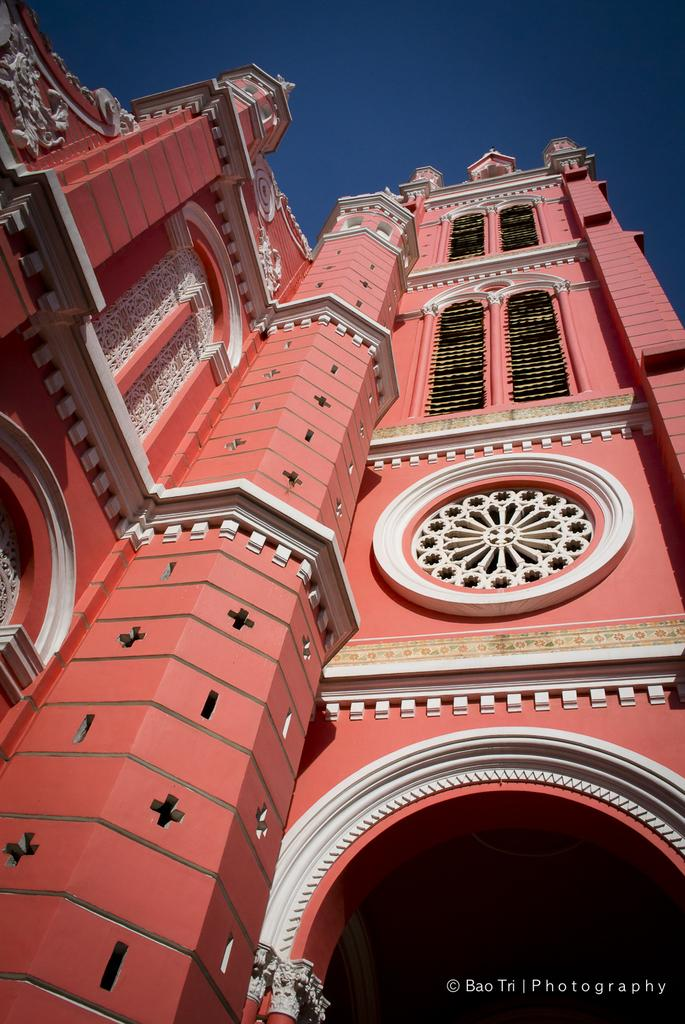What is the main subject of the image? The main subject of the image is a huge building. What colors can be seen on the building? The building is red, white, and black in color. What can be seen in the background of the image? The sky is visible in the background of the image. What is the name of the sock that is hanging on the building in the image? There is no sock present in the image, and therefore no such object can be observed. 